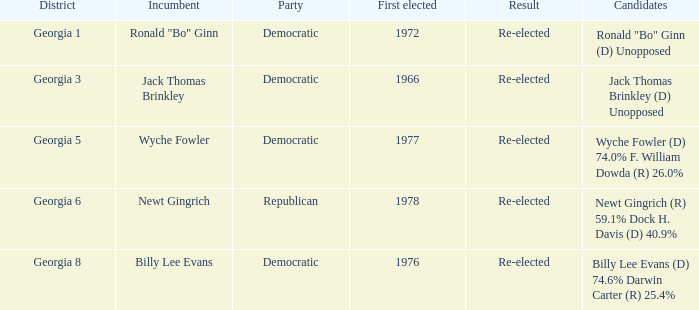9%? 1.0. 